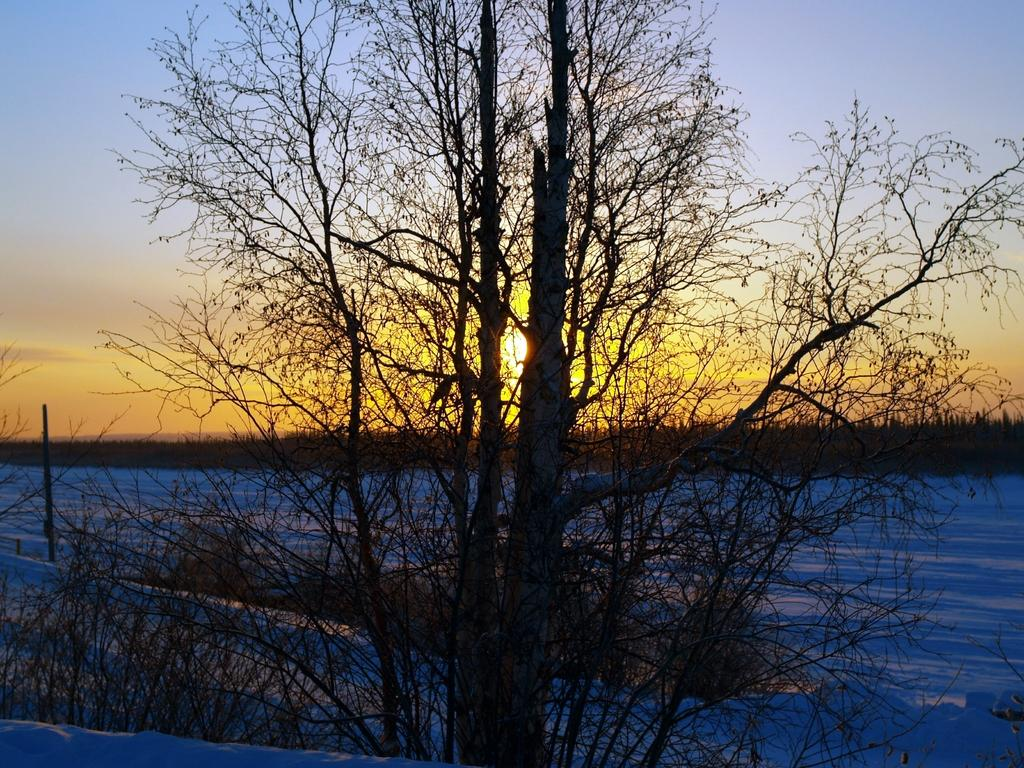What is the main object in the foreground of the image? There is a tree in the image. What is the color of the tree? The tree is black in color. What can be seen on the ground in the background of the image? There is snow on the ground in the background. What else is visible in the background of the image? There are other trees and the sky visible in the background. Can the sun be seen in the image? Yes, the sun is observable in the sky. What type of toothbrush is the giant using in the image? There are no giants or toothbrushes present in the image. What color is the crayon that the tree is holding in the image? There are no crayons or trees holding objects in the image. 